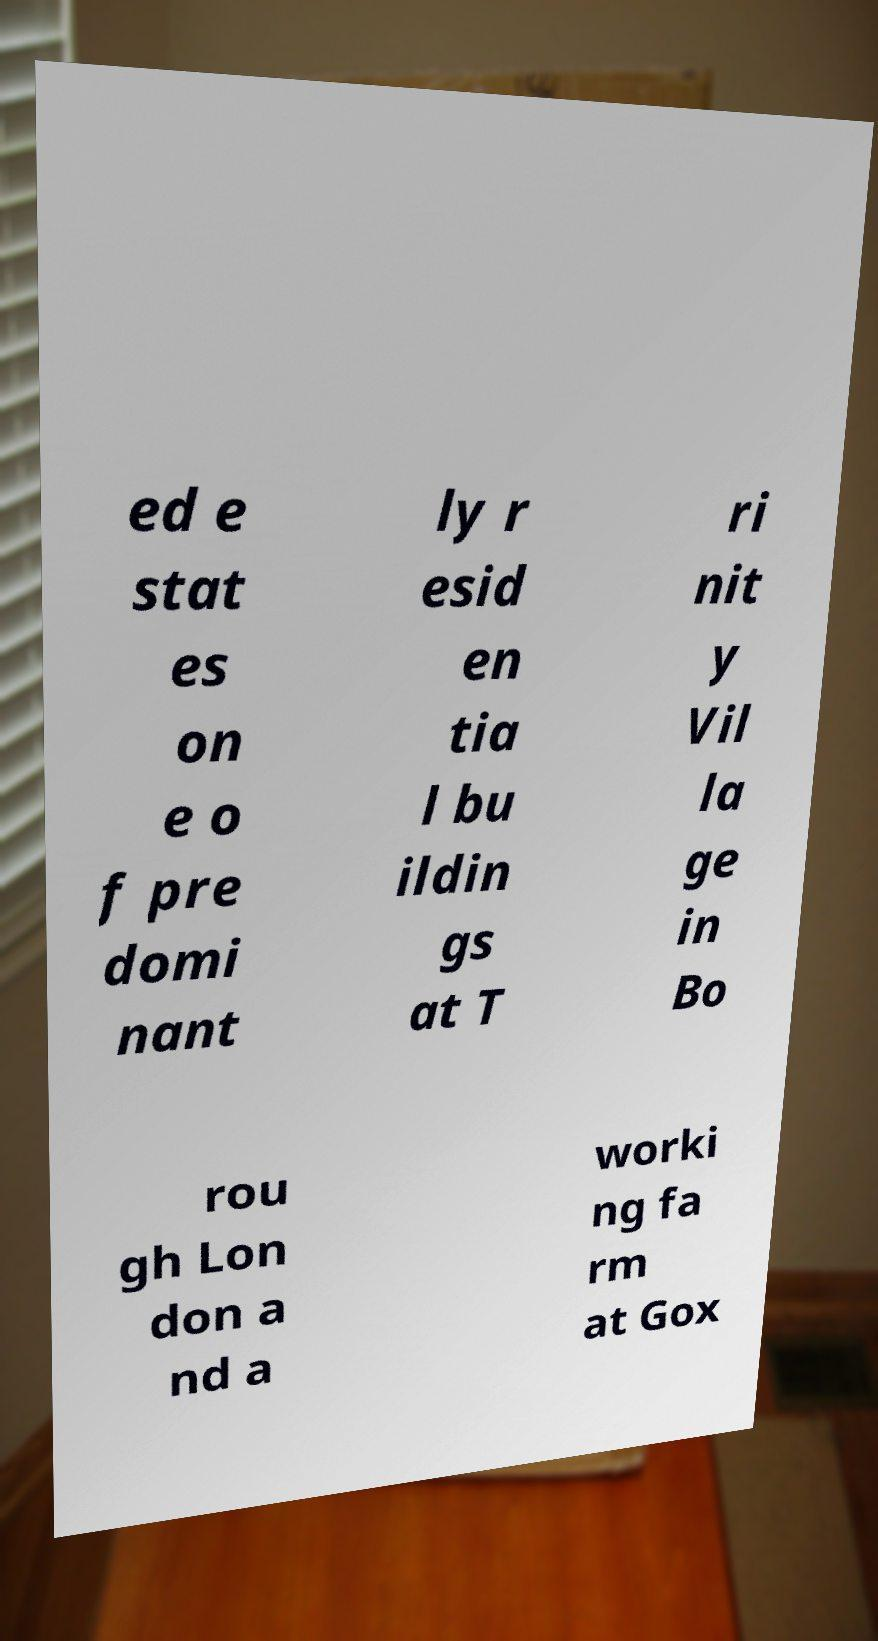Please identify and transcribe the text found in this image. ed e stat es on e o f pre domi nant ly r esid en tia l bu ildin gs at T ri nit y Vil la ge in Bo rou gh Lon don a nd a worki ng fa rm at Gox 